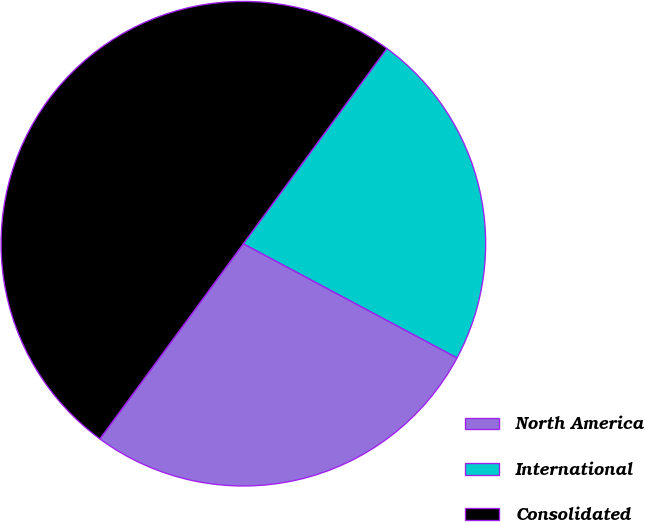<chart> <loc_0><loc_0><loc_500><loc_500><pie_chart><fcel>North America<fcel>International<fcel>Consolidated<nl><fcel>27.28%<fcel>22.72%<fcel>50.0%<nl></chart> 